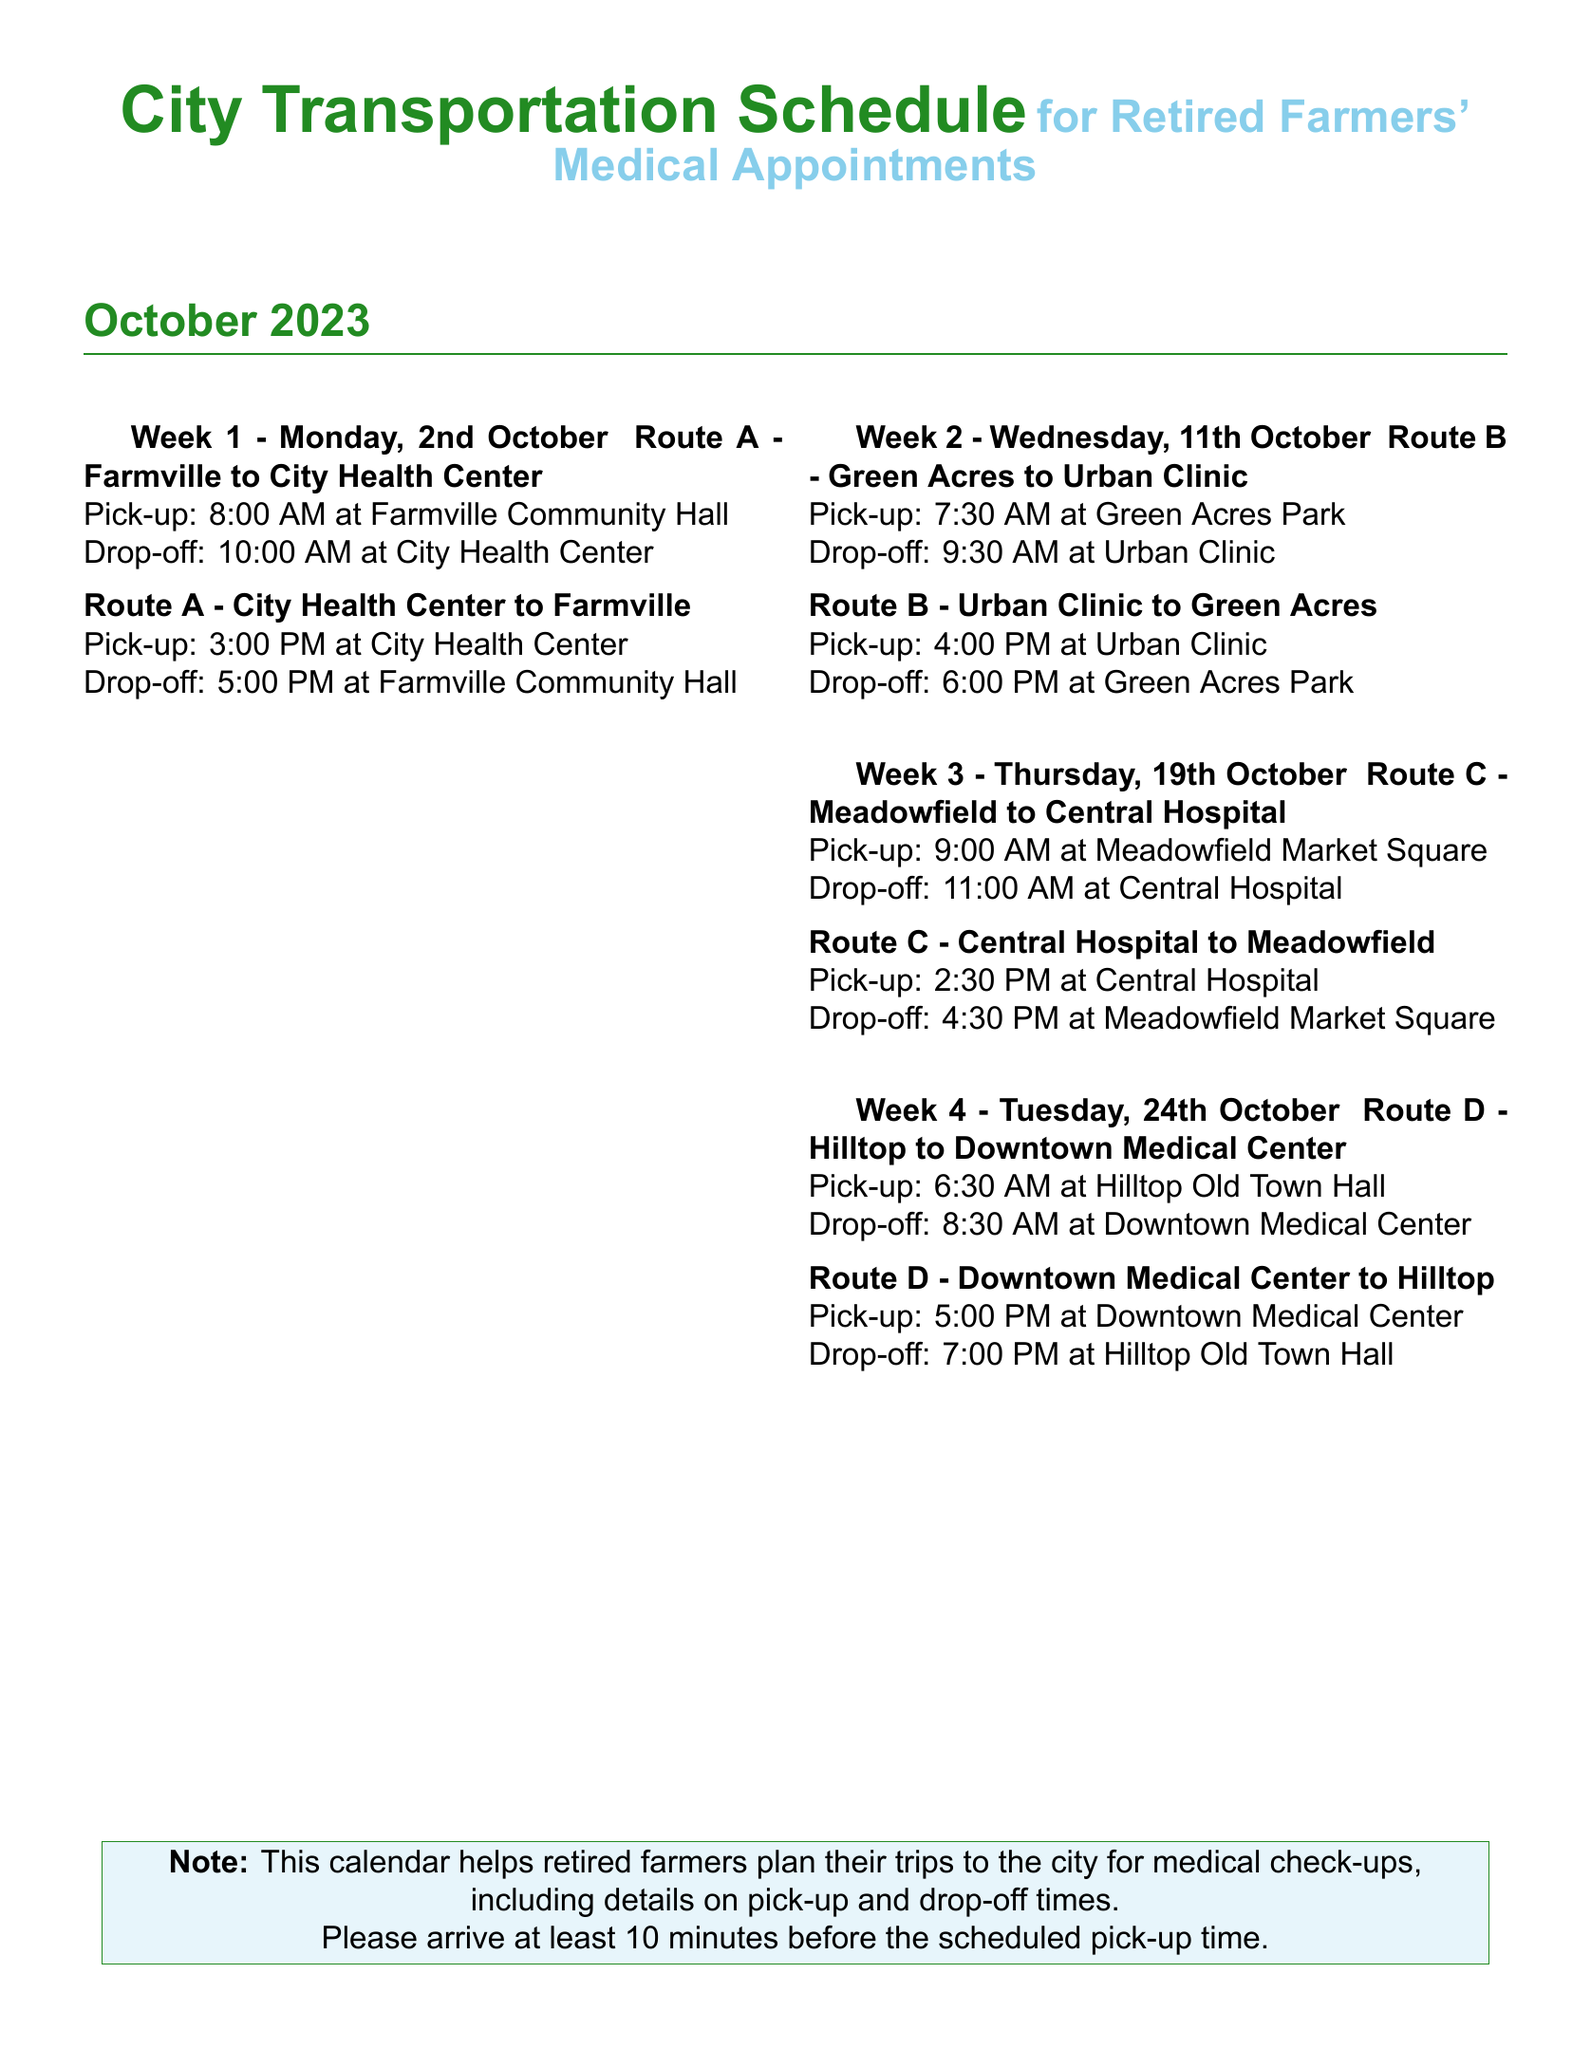What is the pick-up time for Route A on October 2nd? The pick-up time for Route A on October 2nd is stated in the document as 8:00 AM at Farmville Community Hall.
Answer: 8:00 AM What is the drop-off location for Route C on October 19th? The drop-off location for Route C on October 19th is specified as Meadowfield Market Square.
Answer: Meadowfield Market Square How many routes are available in October? By counting the routes listed for each week in the document, there are 4 routes mentioned.
Answer: 4 Which route operates on October 11th? The route operating on October 11th is identified as Route B, connecting Green Acres and Urban Clinic.
Answer: Route B What time should farmers arrive at the pick-up location according to the note? The note advises farmers to arrive at least 10 minutes before the scheduled pick-up time.
Answer: 10 minutes What is the drop-off time for Route D on October 24th? The drop-off time for Route D on October 24th is mentioned as 7:00 PM at Hilltop Old Town Hall.
Answer: 7:00 PM Which week includes Route B? The document mentions that Route B is scheduled for the second week of October, specifically on 11th October.
Answer: Week 2 What is the earliest pick-up time listed in the document? The earliest pick-up time is recorded as 6:30 AM for Route D on October 24th.
Answer: 6:30 AM 